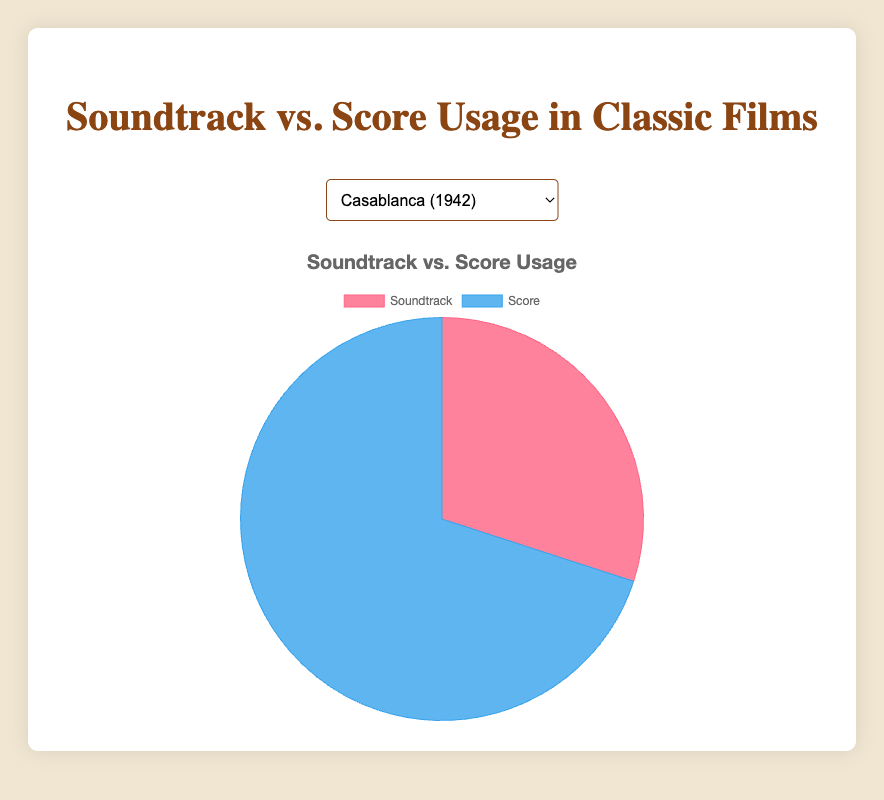Which film has the highest usage of Score? By looking at each film's pie chart data, the movie "Ben-Hur" has the highest Score usage at 95%.
Answer: Ben-Hur Which film has a greater percentage of Soundtrack usage, “The Godfather” or “Chinatown”? "The Godfather" has a Soundtrack usage of 40%, while "Chinatown" has 35%, so "The Godfather" has a greater percentage.
Answer: The Godfather What is the difference in Score usage between "Psycho" and "Casablanca"? "Psycho" has a Score usage of 90% and "Casablanca" has 70%. The difference is 90% - 70% = 20%.
Answer: 20% Out of "Vertigo" and "Gone with the Wind", which has a lower Soundtrack percentage, and by how much? "Vertigo" has a 15% Soundtrack usage while "Gone with the Wind" has 25%. The decrease is 25% - 15% = 10%.
Answer: Vertigo, 10% What is the average Score percentage usage across all films? The Score percentages are 70, 75, 80, 60, 90, 65, 85, 95. Summing these gives 620. There are 8 films, so the average is 620/8 = 77.5%.
Answer: 77.5% Which film has the largest discrepancy between Soundtrack and Score usage? By looking at the differences, "Ben-Hur" has 5% Soundtrack and 95% Score, resulting in a discrepancy of 90%.
Answer: Ben-Hur What is the combined percentage of Soundtrack usage for "Casablanca" and "Gone with the Wind"? "Casablanca" has 30% and "Gone with the Wind" has 25%, so combined they are 30% + 25% = 55%.
Answer: 55% Among "Lawrence of Arabia", "Psycho", and "Chinatown", which film uses the least Score? "Lawrence of Arabia" has 80% Score, "Psycho" 90%, and "Chinatown" 65%. So, "Chinatown" uses the least Score at 65%.
Answer: Chinatown How much more Soundtrack does "The Godfather" use compared to "Casablanca"? "The Godfather" has 40% Soundtrack and "Casablanca" 30%. The difference is 40% - 30% = 10%.
Answer: 10% What is the ratio of Soundtrack to Score usage for "Vertigo"? "Vertigo" has 15% Soundtrack and 85% Score. The ratio is 15:85, which simplifies to 3:17.
Answer: 3:17 